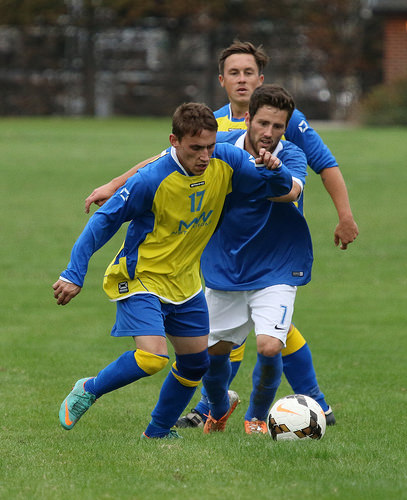<image>
Can you confirm if the man is to the left of the man? Yes. From this viewpoint, the man is positioned to the left side relative to the man. 